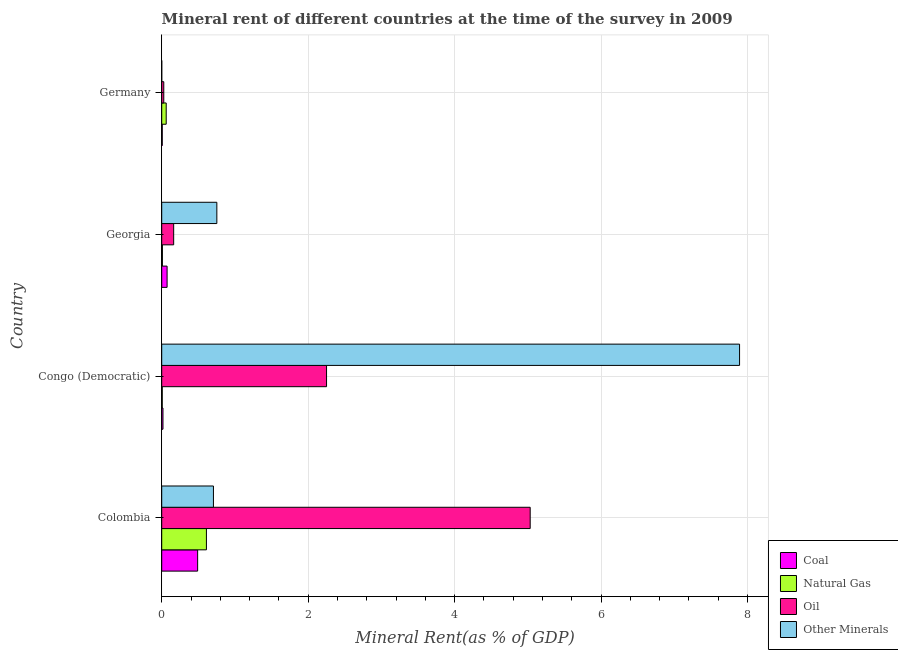How many groups of bars are there?
Offer a terse response. 4. Are the number of bars per tick equal to the number of legend labels?
Your response must be concise. Yes. Are the number of bars on each tick of the Y-axis equal?
Offer a very short reply. Yes. How many bars are there on the 4th tick from the top?
Offer a terse response. 4. How many bars are there on the 1st tick from the bottom?
Provide a short and direct response. 4. What is the label of the 1st group of bars from the top?
Offer a terse response. Germany. In how many cases, is the number of bars for a given country not equal to the number of legend labels?
Your answer should be very brief. 0. What is the oil rent in Congo (Democratic)?
Give a very brief answer. 2.25. Across all countries, what is the maximum oil rent?
Offer a terse response. 5.03. Across all countries, what is the minimum coal rent?
Give a very brief answer. 0.01. In which country was the  rent of other minerals minimum?
Ensure brevity in your answer.  Germany. What is the total coal rent in the graph?
Keep it short and to the point. 0.59. What is the difference between the oil rent in Colombia and that in Germany?
Offer a very short reply. 5. What is the difference between the oil rent in Colombia and the natural gas rent in Congo (Democratic)?
Provide a succinct answer. 5.02. What is the average coal rent per country?
Make the answer very short. 0.15. What is the difference between the  rent of other minerals and coal rent in Georgia?
Provide a short and direct response. 0.68. In how many countries, is the  rent of other minerals greater than 7.2 %?
Offer a very short reply. 1. What is the ratio of the natural gas rent in Congo (Democratic) to that in Georgia?
Offer a very short reply. 0.78. Is the oil rent in Georgia less than that in Germany?
Provide a short and direct response. No. Is the difference between the coal rent in Georgia and Germany greater than the difference between the oil rent in Georgia and Germany?
Keep it short and to the point. No. What is the difference between the highest and the second highest coal rent?
Make the answer very short. 0.42. What is the difference between the highest and the lowest  rent of other minerals?
Your answer should be very brief. 7.89. In how many countries, is the coal rent greater than the average coal rent taken over all countries?
Your answer should be compact. 1. What does the 2nd bar from the top in Congo (Democratic) represents?
Make the answer very short. Oil. What does the 3rd bar from the bottom in Georgia represents?
Your answer should be very brief. Oil. Are all the bars in the graph horizontal?
Your answer should be very brief. Yes. How many countries are there in the graph?
Provide a succinct answer. 4. What is the difference between two consecutive major ticks on the X-axis?
Provide a succinct answer. 2. Are the values on the major ticks of X-axis written in scientific E-notation?
Provide a short and direct response. No. Does the graph contain any zero values?
Provide a short and direct response. No. Does the graph contain grids?
Offer a very short reply. Yes. What is the title of the graph?
Make the answer very short. Mineral rent of different countries at the time of the survey in 2009. Does "Second 20% of population" appear as one of the legend labels in the graph?
Provide a short and direct response. No. What is the label or title of the X-axis?
Your answer should be compact. Mineral Rent(as % of GDP). What is the label or title of the Y-axis?
Your answer should be very brief. Country. What is the Mineral Rent(as % of GDP) in Coal in Colombia?
Offer a very short reply. 0.49. What is the Mineral Rent(as % of GDP) of Natural Gas in Colombia?
Provide a short and direct response. 0.61. What is the Mineral Rent(as % of GDP) in Oil in Colombia?
Make the answer very short. 5.03. What is the Mineral Rent(as % of GDP) of Other Minerals in Colombia?
Keep it short and to the point. 0.71. What is the Mineral Rent(as % of GDP) in Coal in Congo (Democratic)?
Your answer should be very brief. 0.02. What is the Mineral Rent(as % of GDP) in Natural Gas in Congo (Democratic)?
Offer a very short reply. 0.01. What is the Mineral Rent(as % of GDP) in Oil in Congo (Democratic)?
Give a very brief answer. 2.25. What is the Mineral Rent(as % of GDP) in Other Minerals in Congo (Democratic)?
Provide a succinct answer. 7.89. What is the Mineral Rent(as % of GDP) in Coal in Georgia?
Offer a very short reply. 0.07. What is the Mineral Rent(as % of GDP) in Natural Gas in Georgia?
Offer a very short reply. 0.01. What is the Mineral Rent(as % of GDP) in Oil in Georgia?
Provide a succinct answer. 0.16. What is the Mineral Rent(as % of GDP) of Other Minerals in Georgia?
Provide a short and direct response. 0.75. What is the Mineral Rent(as % of GDP) in Coal in Germany?
Offer a very short reply. 0.01. What is the Mineral Rent(as % of GDP) of Natural Gas in Germany?
Offer a very short reply. 0.06. What is the Mineral Rent(as % of GDP) in Oil in Germany?
Offer a terse response. 0.03. What is the Mineral Rent(as % of GDP) of Other Minerals in Germany?
Offer a very short reply. 0. Across all countries, what is the maximum Mineral Rent(as % of GDP) in Coal?
Provide a succinct answer. 0.49. Across all countries, what is the maximum Mineral Rent(as % of GDP) of Natural Gas?
Offer a very short reply. 0.61. Across all countries, what is the maximum Mineral Rent(as % of GDP) in Oil?
Offer a very short reply. 5.03. Across all countries, what is the maximum Mineral Rent(as % of GDP) in Other Minerals?
Make the answer very short. 7.89. Across all countries, what is the minimum Mineral Rent(as % of GDP) in Coal?
Keep it short and to the point. 0.01. Across all countries, what is the minimum Mineral Rent(as % of GDP) in Natural Gas?
Give a very brief answer. 0.01. Across all countries, what is the minimum Mineral Rent(as % of GDP) of Oil?
Give a very brief answer. 0.03. Across all countries, what is the minimum Mineral Rent(as % of GDP) of Other Minerals?
Your answer should be compact. 0. What is the total Mineral Rent(as % of GDP) of Coal in the graph?
Your answer should be compact. 0.59. What is the total Mineral Rent(as % of GDP) of Natural Gas in the graph?
Offer a terse response. 0.69. What is the total Mineral Rent(as % of GDP) of Oil in the graph?
Your response must be concise. 7.47. What is the total Mineral Rent(as % of GDP) of Other Minerals in the graph?
Provide a short and direct response. 9.35. What is the difference between the Mineral Rent(as % of GDP) of Coal in Colombia and that in Congo (Democratic)?
Give a very brief answer. 0.47. What is the difference between the Mineral Rent(as % of GDP) of Natural Gas in Colombia and that in Congo (Democratic)?
Your response must be concise. 0.6. What is the difference between the Mineral Rent(as % of GDP) of Oil in Colombia and that in Congo (Democratic)?
Offer a very short reply. 2.78. What is the difference between the Mineral Rent(as % of GDP) of Other Minerals in Colombia and that in Congo (Democratic)?
Your answer should be very brief. -7.19. What is the difference between the Mineral Rent(as % of GDP) of Coal in Colombia and that in Georgia?
Your response must be concise. 0.42. What is the difference between the Mineral Rent(as % of GDP) in Natural Gas in Colombia and that in Georgia?
Make the answer very short. 0.6. What is the difference between the Mineral Rent(as % of GDP) in Oil in Colombia and that in Georgia?
Your answer should be very brief. 4.87. What is the difference between the Mineral Rent(as % of GDP) in Other Minerals in Colombia and that in Georgia?
Make the answer very short. -0.05. What is the difference between the Mineral Rent(as % of GDP) in Coal in Colombia and that in Germany?
Your response must be concise. 0.48. What is the difference between the Mineral Rent(as % of GDP) in Natural Gas in Colombia and that in Germany?
Offer a terse response. 0.55. What is the difference between the Mineral Rent(as % of GDP) of Oil in Colombia and that in Germany?
Provide a succinct answer. 5. What is the difference between the Mineral Rent(as % of GDP) of Other Minerals in Colombia and that in Germany?
Make the answer very short. 0.71. What is the difference between the Mineral Rent(as % of GDP) in Coal in Congo (Democratic) and that in Georgia?
Your response must be concise. -0.06. What is the difference between the Mineral Rent(as % of GDP) of Natural Gas in Congo (Democratic) and that in Georgia?
Provide a succinct answer. -0. What is the difference between the Mineral Rent(as % of GDP) in Oil in Congo (Democratic) and that in Georgia?
Your answer should be very brief. 2.09. What is the difference between the Mineral Rent(as % of GDP) in Other Minerals in Congo (Democratic) and that in Georgia?
Your answer should be very brief. 7.14. What is the difference between the Mineral Rent(as % of GDP) in Coal in Congo (Democratic) and that in Germany?
Give a very brief answer. 0.01. What is the difference between the Mineral Rent(as % of GDP) of Natural Gas in Congo (Democratic) and that in Germany?
Your answer should be very brief. -0.05. What is the difference between the Mineral Rent(as % of GDP) of Oil in Congo (Democratic) and that in Germany?
Your answer should be very brief. 2.22. What is the difference between the Mineral Rent(as % of GDP) of Other Minerals in Congo (Democratic) and that in Germany?
Make the answer very short. 7.89. What is the difference between the Mineral Rent(as % of GDP) of Coal in Georgia and that in Germany?
Ensure brevity in your answer.  0.07. What is the difference between the Mineral Rent(as % of GDP) of Natural Gas in Georgia and that in Germany?
Offer a very short reply. -0.05. What is the difference between the Mineral Rent(as % of GDP) of Oil in Georgia and that in Germany?
Ensure brevity in your answer.  0.14. What is the difference between the Mineral Rent(as % of GDP) in Other Minerals in Georgia and that in Germany?
Provide a succinct answer. 0.75. What is the difference between the Mineral Rent(as % of GDP) in Coal in Colombia and the Mineral Rent(as % of GDP) in Natural Gas in Congo (Democratic)?
Provide a short and direct response. 0.48. What is the difference between the Mineral Rent(as % of GDP) of Coal in Colombia and the Mineral Rent(as % of GDP) of Oil in Congo (Democratic)?
Your response must be concise. -1.76. What is the difference between the Mineral Rent(as % of GDP) in Coal in Colombia and the Mineral Rent(as % of GDP) in Other Minerals in Congo (Democratic)?
Provide a short and direct response. -7.4. What is the difference between the Mineral Rent(as % of GDP) in Natural Gas in Colombia and the Mineral Rent(as % of GDP) in Oil in Congo (Democratic)?
Ensure brevity in your answer.  -1.64. What is the difference between the Mineral Rent(as % of GDP) of Natural Gas in Colombia and the Mineral Rent(as % of GDP) of Other Minerals in Congo (Democratic)?
Your answer should be compact. -7.28. What is the difference between the Mineral Rent(as % of GDP) of Oil in Colombia and the Mineral Rent(as % of GDP) of Other Minerals in Congo (Democratic)?
Your answer should be very brief. -2.86. What is the difference between the Mineral Rent(as % of GDP) in Coal in Colombia and the Mineral Rent(as % of GDP) in Natural Gas in Georgia?
Give a very brief answer. 0.48. What is the difference between the Mineral Rent(as % of GDP) of Coal in Colombia and the Mineral Rent(as % of GDP) of Oil in Georgia?
Make the answer very short. 0.33. What is the difference between the Mineral Rent(as % of GDP) in Coal in Colombia and the Mineral Rent(as % of GDP) in Other Minerals in Georgia?
Ensure brevity in your answer.  -0.26. What is the difference between the Mineral Rent(as % of GDP) in Natural Gas in Colombia and the Mineral Rent(as % of GDP) in Oil in Georgia?
Your answer should be very brief. 0.45. What is the difference between the Mineral Rent(as % of GDP) in Natural Gas in Colombia and the Mineral Rent(as % of GDP) in Other Minerals in Georgia?
Keep it short and to the point. -0.14. What is the difference between the Mineral Rent(as % of GDP) in Oil in Colombia and the Mineral Rent(as % of GDP) in Other Minerals in Georgia?
Provide a succinct answer. 4.28. What is the difference between the Mineral Rent(as % of GDP) in Coal in Colombia and the Mineral Rent(as % of GDP) in Natural Gas in Germany?
Your answer should be very brief. 0.43. What is the difference between the Mineral Rent(as % of GDP) of Coal in Colombia and the Mineral Rent(as % of GDP) of Oil in Germany?
Keep it short and to the point. 0.46. What is the difference between the Mineral Rent(as % of GDP) of Coal in Colombia and the Mineral Rent(as % of GDP) of Other Minerals in Germany?
Offer a terse response. 0.49. What is the difference between the Mineral Rent(as % of GDP) in Natural Gas in Colombia and the Mineral Rent(as % of GDP) in Oil in Germany?
Offer a terse response. 0.58. What is the difference between the Mineral Rent(as % of GDP) in Natural Gas in Colombia and the Mineral Rent(as % of GDP) in Other Minerals in Germany?
Offer a very short reply. 0.61. What is the difference between the Mineral Rent(as % of GDP) of Oil in Colombia and the Mineral Rent(as % of GDP) of Other Minerals in Germany?
Offer a very short reply. 5.03. What is the difference between the Mineral Rent(as % of GDP) of Coal in Congo (Democratic) and the Mineral Rent(as % of GDP) of Natural Gas in Georgia?
Ensure brevity in your answer.  0.01. What is the difference between the Mineral Rent(as % of GDP) in Coal in Congo (Democratic) and the Mineral Rent(as % of GDP) in Oil in Georgia?
Your answer should be compact. -0.15. What is the difference between the Mineral Rent(as % of GDP) in Coal in Congo (Democratic) and the Mineral Rent(as % of GDP) in Other Minerals in Georgia?
Provide a short and direct response. -0.74. What is the difference between the Mineral Rent(as % of GDP) of Natural Gas in Congo (Democratic) and the Mineral Rent(as % of GDP) of Oil in Georgia?
Provide a succinct answer. -0.16. What is the difference between the Mineral Rent(as % of GDP) of Natural Gas in Congo (Democratic) and the Mineral Rent(as % of GDP) of Other Minerals in Georgia?
Keep it short and to the point. -0.75. What is the difference between the Mineral Rent(as % of GDP) in Oil in Congo (Democratic) and the Mineral Rent(as % of GDP) in Other Minerals in Georgia?
Ensure brevity in your answer.  1.5. What is the difference between the Mineral Rent(as % of GDP) of Coal in Congo (Democratic) and the Mineral Rent(as % of GDP) of Natural Gas in Germany?
Keep it short and to the point. -0.04. What is the difference between the Mineral Rent(as % of GDP) in Coal in Congo (Democratic) and the Mineral Rent(as % of GDP) in Oil in Germany?
Your answer should be compact. -0.01. What is the difference between the Mineral Rent(as % of GDP) in Coal in Congo (Democratic) and the Mineral Rent(as % of GDP) in Other Minerals in Germany?
Offer a terse response. 0.02. What is the difference between the Mineral Rent(as % of GDP) of Natural Gas in Congo (Democratic) and the Mineral Rent(as % of GDP) of Oil in Germany?
Make the answer very short. -0.02. What is the difference between the Mineral Rent(as % of GDP) of Natural Gas in Congo (Democratic) and the Mineral Rent(as % of GDP) of Other Minerals in Germany?
Your answer should be compact. 0.01. What is the difference between the Mineral Rent(as % of GDP) of Oil in Congo (Democratic) and the Mineral Rent(as % of GDP) of Other Minerals in Germany?
Offer a very short reply. 2.25. What is the difference between the Mineral Rent(as % of GDP) in Coal in Georgia and the Mineral Rent(as % of GDP) in Natural Gas in Germany?
Provide a short and direct response. 0.01. What is the difference between the Mineral Rent(as % of GDP) of Coal in Georgia and the Mineral Rent(as % of GDP) of Oil in Germany?
Offer a terse response. 0.05. What is the difference between the Mineral Rent(as % of GDP) in Coal in Georgia and the Mineral Rent(as % of GDP) in Other Minerals in Germany?
Your response must be concise. 0.07. What is the difference between the Mineral Rent(as % of GDP) in Natural Gas in Georgia and the Mineral Rent(as % of GDP) in Oil in Germany?
Your answer should be compact. -0.02. What is the difference between the Mineral Rent(as % of GDP) in Natural Gas in Georgia and the Mineral Rent(as % of GDP) in Other Minerals in Germany?
Make the answer very short. 0.01. What is the difference between the Mineral Rent(as % of GDP) of Oil in Georgia and the Mineral Rent(as % of GDP) of Other Minerals in Germany?
Provide a succinct answer. 0.16. What is the average Mineral Rent(as % of GDP) of Coal per country?
Offer a terse response. 0.15. What is the average Mineral Rent(as % of GDP) of Natural Gas per country?
Provide a short and direct response. 0.17. What is the average Mineral Rent(as % of GDP) in Oil per country?
Keep it short and to the point. 1.87. What is the average Mineral Rent(as % of GDP) in Other Minerals per country?
Your answer should be compact. 2.34. What is the difference between the Mineral Rent(as % of GDP) of Coal and Mineral Rent(as % of GDP) of Natural Gas in Colombia?
Offer a very short reply. -0.12. What is the difference between the Mineral Rent(as % of GDP) in Coal and Mineral Rent(as % of GDP) in Oil in Colombia?
Provide a short and direct response. -4.54. What is the difference between the Mineral Rent(as % of GDP) in Coal and Mineral Rent(as % of GDP) in Other Minerals in Colombia?
Your answer should be compact. -0.22. What is the difference between the Mineral Rent(as % of GDP) of Natural Gas and Mineral Rent(as % of GDP) of Oil in Colombia?
Give a very brief answer. -4.42. What is the difference between the Mineral Rent(as % of GDP) of Natural Gas and Mineral Rent(as % of GDP) of Other Minerals in Colombia?
Keep it short and to the point. -0.1. What is the difference between the Mineral Rent(as % of GDP) in Oil and Mineral Rent(as % of GDP) in Other Minerals in Colombia?
Offer a very short reply. 4.33. What is the difference between the Mineral Rent(as % of GDP) of Coal and Mineral Rent(as % of GDP) of Natural Gas in Congo (Democratic)?
Offer a very short reply. 0.01. What is the difference between the Mineral Rent(as % of GDP) of Coal and Mineral Rent(as % of GDP) of Oil in Congo (Democratic)?
Your answer should be compact. -2.23. What is the difference between the Mineral Rent(as % of GDP) of Coal and Mineral Rent(as % of GDP) of Other Minerals in Congo (Democratic)?
Offer a very short reply. -7.87. What is the difference between the Mineral Rent(as % of GDP) of Natural Gas and Mineral Rent(as % of GDP) of Oil in Congo (Democratic)?
Ensure brevity in your answer.  -2.24. What is the difference between the Mineral Rent(as % of GDP) of Natural Gas and Mineral Rent(as % of GDP) of Other Minerals in Congo (Democratic)?
Provide a short and direct response. -7.88. What is the difference between the Mineral Rent(as % of GDP) of Oil and Mineral Rent(as % of GDP) of Other Minerals in Congo (Democratic)?
Provide a succinct answer. -5.64. What is the difference between the Mineral Rent(as % of GDP) in Coal and Mineral Rent(as % of GDP) in Natural Gas in Georgia?
Offer a terse response. 0.06. What is the difference between the Mineral Rent(as % of GDP) in Coal and Mineral Rent(as % of GDP) in Oil in Georgia?
Keep it short and to the point. -0.09. What is the difference between the Mineral Rent(as % of GDP) of Coal and Mineral Rent(as % of GDP) of Other Minerals in Georgia?
Provide a succinct answer. -0.68. What is the difference between the Mineral Rent(as % of GDP) in Natural Gas and Mineral Rent(as % of GDP) in Oil in Georgia?
Offer a very short reply. -0.15. What is the difference between the Mineral Rent(as % of GDP) in Natural Gas and Mineral Rent(as % of GDP) in Other Minerals in Georgia?
Provide a short and direct response. -0.74. What is the difference between the Mineral Rent(as % of GDP) of Oil and Mineral Rent(as % of GDP) of Other Minerals in Georgia?
Your response must be concise. -0.59. What is the difference between the Mineral Rent(as % of GDP) in Coal and Mineral Rent(as % of GDP) in Natural Gas in Germany?
Offer a terse response. -0.05. What is the difference between the Mineral Rent(as % of GDP) of Coal and Mineral Rent(as % of GDP) of Oil in Germany?
Make the answer very short. -0.02. What is the difference between the Mineral Rent(as % of GDP) in Coal and Mineral Rent(as % of GDP) in Other Minerals in Germany?
Ensure brevity in your answer.  0.01. What is the difference between the Mineral Rent(as % of GDP) of Natural Gas and Mineral Rent(as % of GDP) of Oil in Germany?
Ensure brevity in your answer.  0.03. What is the difference between the Mineral Rent(as % of GDP) of Natural Gas and Mineral Rent(as % of GDP) of Other Minerals in Germany?
Offer a terse response. 0.06. What is the difference between the Mineral Rent(as % of GDP) of Oil and Mineral Rent(as % of GDP) of Other Minerals in Germany?
Make the answer very short. 0.03. What is the ratio of the Mineral Rent(as % of GDP) in Coal in Colombia to that in Congo (Democratic)?
Provide a succinct answer. 28.7. What is the ratio of the Mineral Rent(as % of GDP) in Natural Gas in Colombia to that in Congo (Democratic)?
Offer a very short reply. 82.93. What is the ratio of the Mineral Rent(as % of GDP) of Oil in Colombia to that in Congo (Democratic)?
Your response must be concise. 2.24. What is the ratio of the Mineral Rent(as % of GDP) in Other Minerals in Colombia to that in Congo (Democratic)?
Offer a terse response. 0.09. What is the ratio of the Mineral Rent(as % of GDP) of Coal in Colombia to that in Georgia?
Offer a terse response. 6.67. What is the ratio of the Mineral Rent(as % of GDP) of Natural Gas in Colombia to that in Georgia?
Provide a succinct answer. 64.95. What is the ratio of the Mineral Rent(as % of GDP) of Oil in Colombia to that in Georgia?
Keep it short and to the point. 30.82. What is the ratio of the Mineral Rent(as % of GDP) of Other Minerals in Colombia to that in Georgia?
Offer a terse response. 0.94. What is the ratio of the Mineral Rent(as % of GDP) of Coal in Colombia to that in Germany?
Keep it short and to the point. 65.95. What is the ratio of the Mineral Rent(as % of GDP) of Natural Gas in Colombia to that in Germany?
Offer a very short reply. 9.96. What is the ratio of the Mineral Rent(as % of GDP) of Oil in Colombia to that in Germany?
Your answer should be compact. 178.3. What is the ratio of the Mineral Rent(as % of GDP) in Other Minerals in Colombia to that in Germany?
Your answer should be compact. 1756.07. What is the ratio of the Mineral Rent(as % of GDP) of Coal in Congo (Democratic) to that in Georgia?
Ensure brevity in your answer.  0.23. What is the ratio of the Mineral Rent(as % of GDP) in Natural Gas in Congo (Democratic) to that in Georgia?
Keep it short and to the point. 0.78. What is the ratio of the Mineral Rent(as % of GDP) in Oil in Congo (Democratic) to that in Georgia?
Provide a short and direct response. 13.79. What is the ratio of the Mineral Rent(as % of GDP) in Other Minerals in Congo (Democratic) to that in Georgia?
Give a very brief answer. 10.48. What is the ratio of the Mineral Rent(as % of GDP) in Coal in Congo (Democratic) to that in Germany?
Offer a terse response. 2.3. What is the ratio of the Mineral Rent(as % of GDP) in Natural Gas in Congo (Democratic) to that in Germany?
Offer a very short reply. 0.12. What is the ratio of the Mineral Rent(as % of GDP) of Oil in Congo (Democratic) to that in Germany?
Offer a very short reply. 79.76. What is the ratio of the Mineral Rent(as % of GDP) of Other Minerals in Congo (Democratic) to that in Germany?
Offer a very short reply. 1.96e+04. What is the ratio of the Mineral Rent(as % of GDP) of Coal in Georgia to that in Germany?
Offer a very short reply. 9.89. What is the ratio of the Mineral Rent(as % of GDP) in Natural Gas in Georgia to that in Germany?
Offer a very short reply. 0.15. What is the ratio of the Mineral Rent(as % of GDP) of Oil in Georgia to that in Germany?
Your answer should be compact. 5.79. What is the ratio of the Mineral Rent(as % of GDP) in Other Minerals in Georgia to that in Germany?
Offer a very short reply. 1871.64. What is the difference between the highest and the second highest Mineral Rent(as % of GDP) of Coal?
Offer a terse response. 0.42. What is the difference between the highest and the second highest Mineral Rent(as % of GDP) in Natural Gas?
Provide a short and direct response. 0.55. What is the difference between the highest and the second highest Mineral Rent(as % of GDP) in Oil?
Ensure brevity in your answer.  2.78. What is the difference between the highest and the second highest Mineral Rent(as % of GDP) in Other Minerals?
Your answer should be very brief. 7.14. What is the difference between the highest and the lowest Mineral Rent(as % of GDP) of Coal?
Your answer should be very brief. 0.48. What is the difference between the highest and the lowest Mineral Rent(as % of GDP) of Natural Gas?
Offer a terse response. 0.6. What is the difference between the highest and the lowest Mineral Rent(as % of GDP) in Oil?
Your answer should be compact. 5. What is the difference between the highest and the lowest Mineral Rent(as % of GDP) in Other Minerals?
Provide a succinct answer. 7.89. 